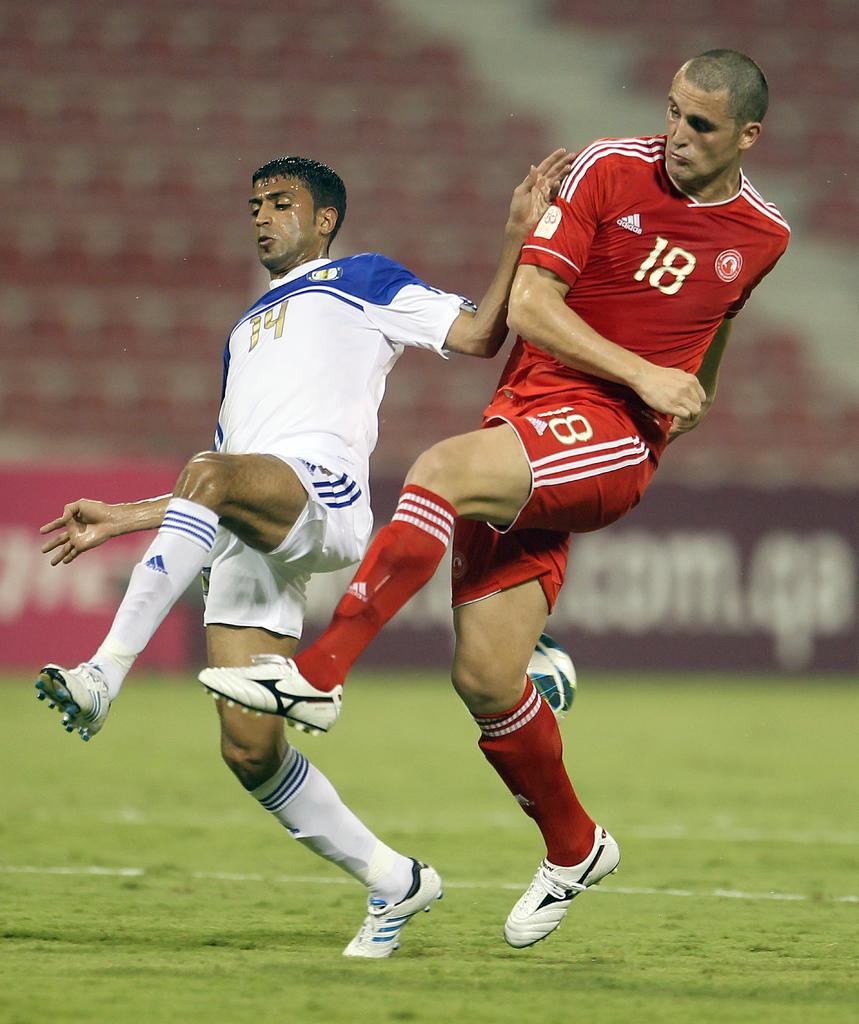<image>
Create a compact narrative representing the image presented. Number 18 in red and number 14 in white are two men playing soccer. 